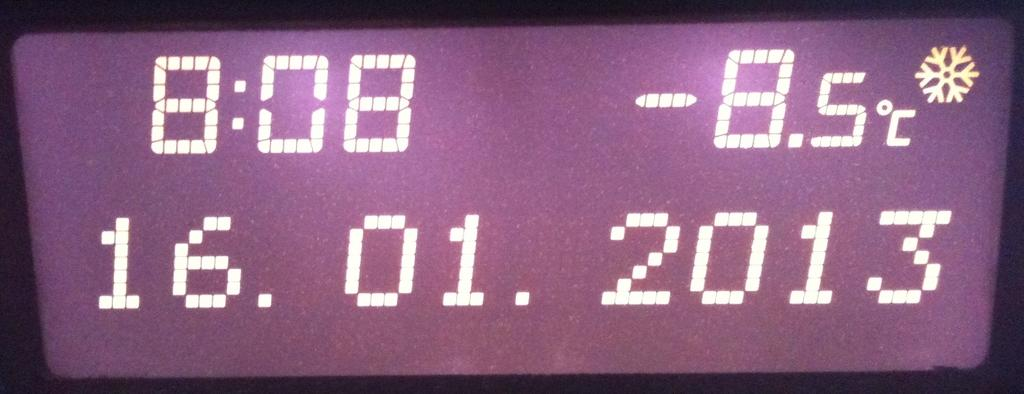<image>
Give a short and clear explanation of the subsequent image. A clock display shows the time as 8:08 and the temperature as -8.5 celsius 